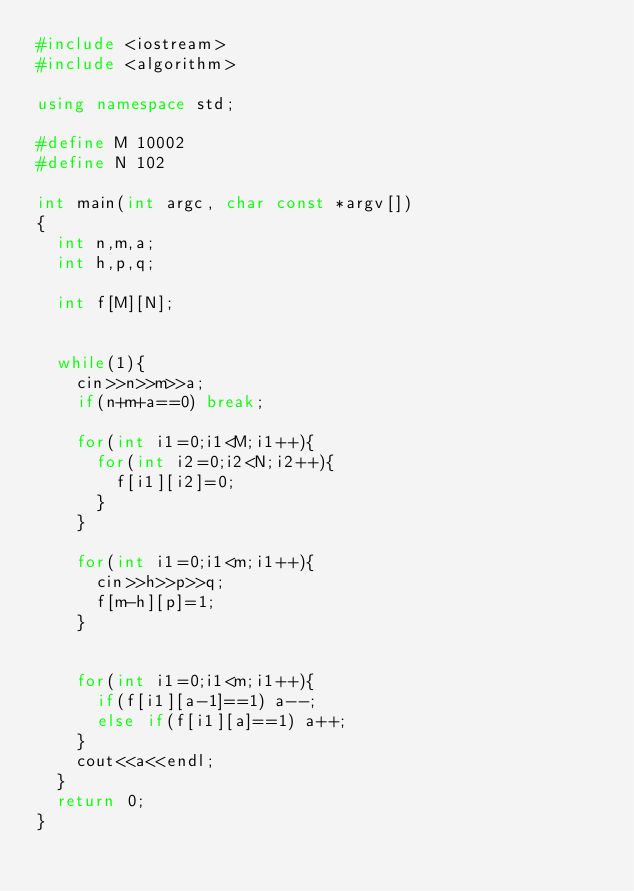<code> <loc_0><loc_0><loc_500><loc_500><_C++_>#include <iostream>
#include <algorithm>

using namespace std;

#define M 10002
#define N 102

int main(int argc, char const *argv[])
{
	int n,m,a;
	int h,p,q;

	int f[M][N];


	while(1){
		cin>>n>>m>>a;
		if(n+m+a==0) break;

		for(int i1=0;i1<M;i1++){
			for(int i2=0;i2<N;i2++){
				f[i1][i2]=0;
			}
		}

		for(int i1=0;i1<m;i1++){
			cin>>h>>p>>q;
			f[m-h][p]=1;
		}


		for(int i1=0;i1<m;i1++){
			if(f[i1][a-1]==1) a--;
			else if(f[i1][a]==1) a++;
		}
		cout<<a<<endl;
	}
	return 0;
}</code> 